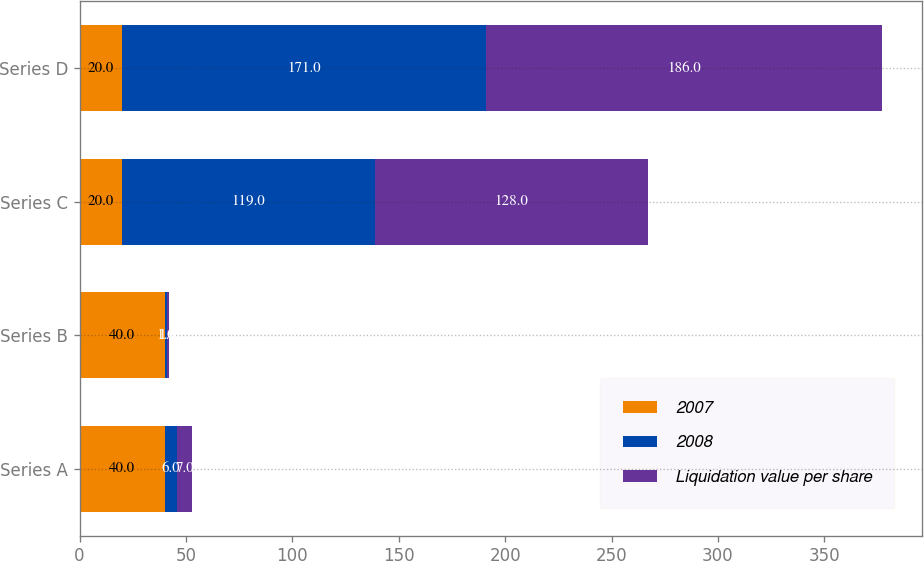Convert chart. <chart><loc_0><loc_0><loc_500><loc_500><stacked_bar_chart><ecel><fcel>Series A<fcel>Series B<fcel>Series C<fcel>Series D<nl><fcel>2007<fcel>40<fcel>40<fcel>20<fcel>20<nl><fcel>2008<fcel>6<fcel>1<fcel>119<fcel>171<nl><fcel>Liquidation value per share<fcel>7<fcel>1<fcel>128<fcel>186<nl></chart> 